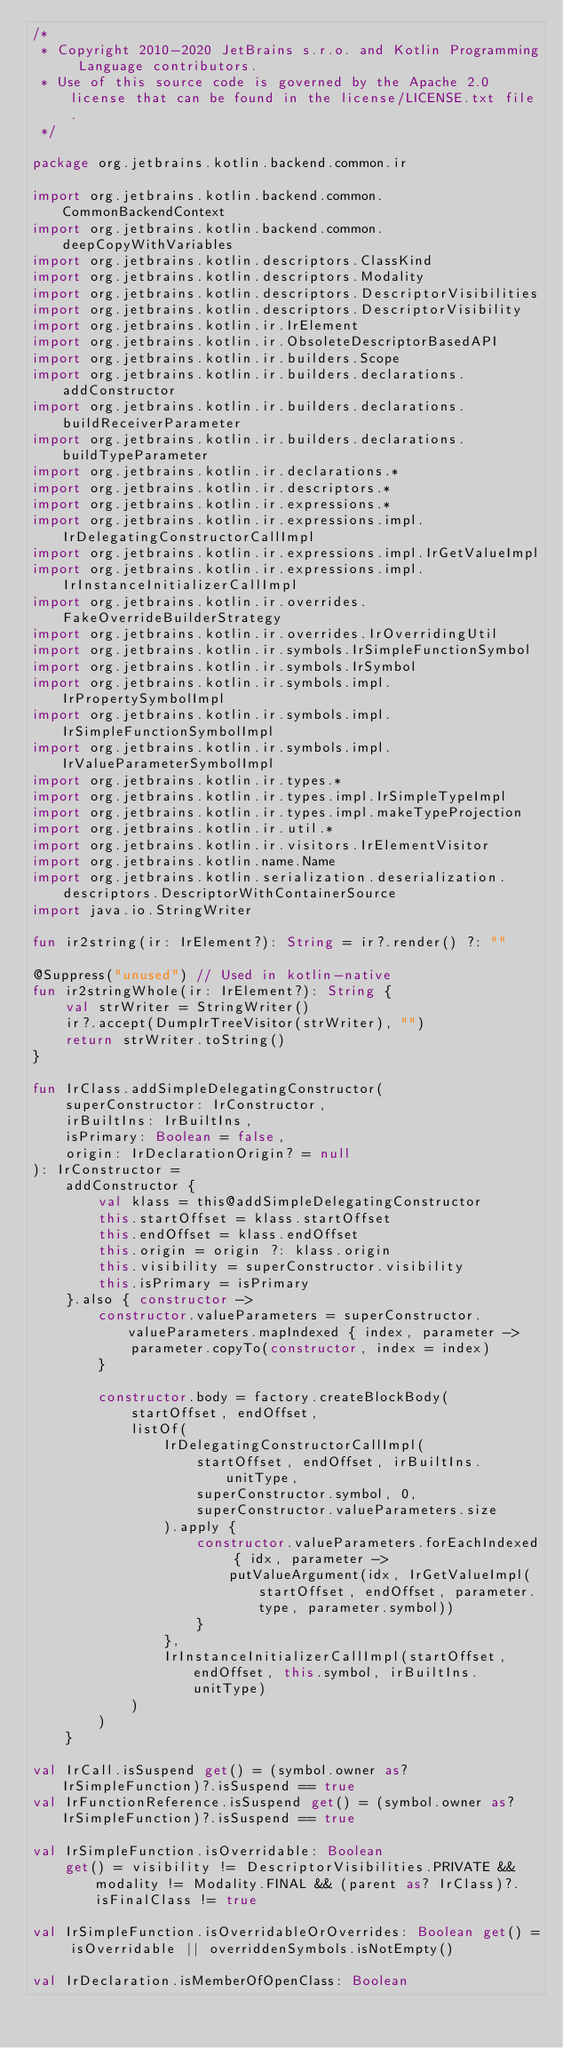<code> <loc_0><loc_0><loc_500><loc_500><_Kotlin_>/*
 * Copyright 2010-2020 JetBrains s.r.o. and Kotlin Programming Language contributors.
 * Use of this source code is governed by the Apache 2.0 license that can be found in the license/LICENSE.txt file.
 */

package org.jetbrains.kotlin.backend.common.ir

import org.jetbrains.kotlin.backend.common.CommonBackendContext
import org.jetbrains.kotlin.backend.common.deepCopyWithVariables
import org.jetbrains.kotlin.descriptors.ClassKind
import org.jetbrains.kotlin.descriptors.Modality
import org.jetbrains.kotlin.descriptors.DescriptorVisibilities
import org.jetbrains.kotlin.descriptors.DescriptorVisibility
import org.jetbrains.kotlin.ir.IrElement
import org.jetbrains.kotlin.ir.ObsoleteDescriptorBasedAPI
import org.jetbrains.kotlin.ir.builders.Scope
import org.jetbrains.kotlin.ir.builders.declarations.addConstructor
import org.jetbrains.kotlin.ir.builders.declarations.buildReceiverParameter
import org.jetbrains.kotlin.ir.builders.declarations.buildTypeParameter
import org.jetbrains.kotlin.ir.declarations.*
import org.jetbrains.kotlin.ir.descriptors.*
import org.jetbrains.kotlin.ir.expressions.*
import org.jetbrains.kotlin.ir.expressions.impl.IrDelegatingConstructorCallImpl
import org.jetbrains.kotlin.ir.expressions.impl.IrGetValueImpl
import org.jetbrains.kotlin.ir.expressions.impl.IrInstanceInitializerCallImpl
import org.jetbrains.kotlin.ir.overrides.FakeOverrideBuilderStrategy
import org.jetbrains.kotlin.ir.overrides.IrOverridingUtil
import org.jetbrains.kotlin.ir.symbols.IrSimpleFunctionSymbol
import org.jetbrains.kotlin.ir.symbols.IrSymbol
import org.jetbrains.kotlin.ir.symbols.impl.IrPropertySymbolImpl
import org.jetbrains.kotlin.ir.symbols.impl.IrSimpleFunctionSymbolImpl
import org.jetbrains.kotlin.ir.symbols.impl.IrValueParameterSymbolImpl
import org.jetbrains.kotlin.ir.types.*
import org.jetbrains.kotlin.ir.types.impl.IrSimpleTypeImpl
import org.jetbrains.kotlin.ir.types.impl.makeTypeProjection
import org.jetbrains.kotlin.ir.util.*
import org.jetbrains.kotlin.ir.visitors.IrElementVisitor
import org.jetbrains.kotlin.name.Name
import org.jetbrains.kotlin.serialization.deserialization.descriptors.DescriptorWithContainerSource
import java.io.StringWriter

fun ir2string(ir: IrElement?): String = ir?.render() ?: ""

@Suppress("unused") // Used in kotlin-native
fun ir2stringWhole(ir: IrElement?): String {
    val strWriter = StringWriter()
    ir?.accept(DumpIrTreeVisitor(strWriter), "")
    return strWriter.toString()
}

fun IrClass.addSimpleDelegatingConstructor(
    superConstructor: IrConstructor,
    irBuiltIns: IrBuiltIns,
    isPrimary: Boolean = false,
    origin: IrDeclarationOrigin? = null
): IrConstructor =
    addConstructor {
        val klass = this@addSimpleDelegatingConstructor
        this.startOffset = klass.startOffset
        this.endOffset = klass.endOffset
        this.origin = origin ?: klass.origin
        this.visibility = superConstructor.visibility
        this.isPrimary = isPrimary
    }.also { constructor ->
        constructor.valueParameters = superConstructor.valueParameters.mapIndexed { index, parameter ->
            parameter.copyTo(constructor, index = index)
        }

        constructor.body = factory.createBlockBody(
            startOffset, endOffset,
            listOf(
                IrDelegatingConstructorCallImpl(
                    startOffset, endOffset, irBuiltIns.unitType,
                    superConstructor.symbol, 0,
                    superConstructor.valueParameters.size
                ).apply {
                    constructor.valueParameters.forEachIndexed { idx, parameter ->
                        putValueArgument(idx, IrGetValueImpl(startOffset, endOffset, parameter.type, parameter.symbol))
                    }
                },
                IrInstanceInitializerCallImpl(startOffset, endOffset, this.symbol, irBuiltIns.unitType)
            )
        )
    }

val IrCall.isSuspend get() = (symbol.owner as? IrSimpleFunction)?.isSuspend == true
val IrFunctionReference.isSuspend get() = (symbol.owner as? IrSimpleFunction)?.isSuspend == true

val IrSimpleFunction.isOverridable: Boolean
    get() = visibility != DescriptorVisibilities.PRIVATE && modality != Modality.FINAL && (parent as? IrClass)?.isFinalClass != true

val IrSimpleFunction.isOverridableOrOverrides: Boolean get() = isOverridable || overriddenSymbols.isNotEmpty()

val IrDeclaration.isMemberOfOpenClass: Boolean</code> 